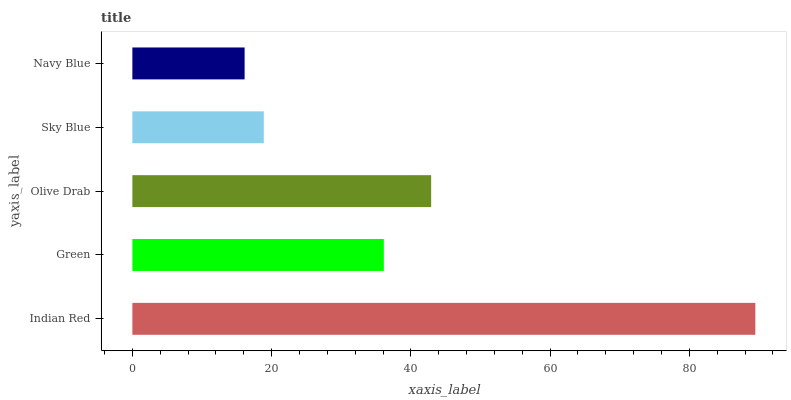Is Navy Blue the minimum?
Answer yes or no. Yes. Is Indian Red the maximum?
Answer yes or no. Yes. Is Green the minimum?
Answer yes or no. No. Is Green the maximum?
Answer yes or no. No. Is Indian Red greater than Green?
Answer yes or no. Yes. Is Green less than Indian Red?
Answer yes or no. Yes. Is Green greater than Indian Red?
Answer yes or no. No. Is Indian Red less than Green?
Answer yes or no. No. Is Green the high median?
Answer yes or no. Yes. Is Green the low median?
Answer yes or no. Yes. Is Indian Red the high median?
Answer yes or no. No. Is Sky Blue the low median?
Answer yes or no. No. 